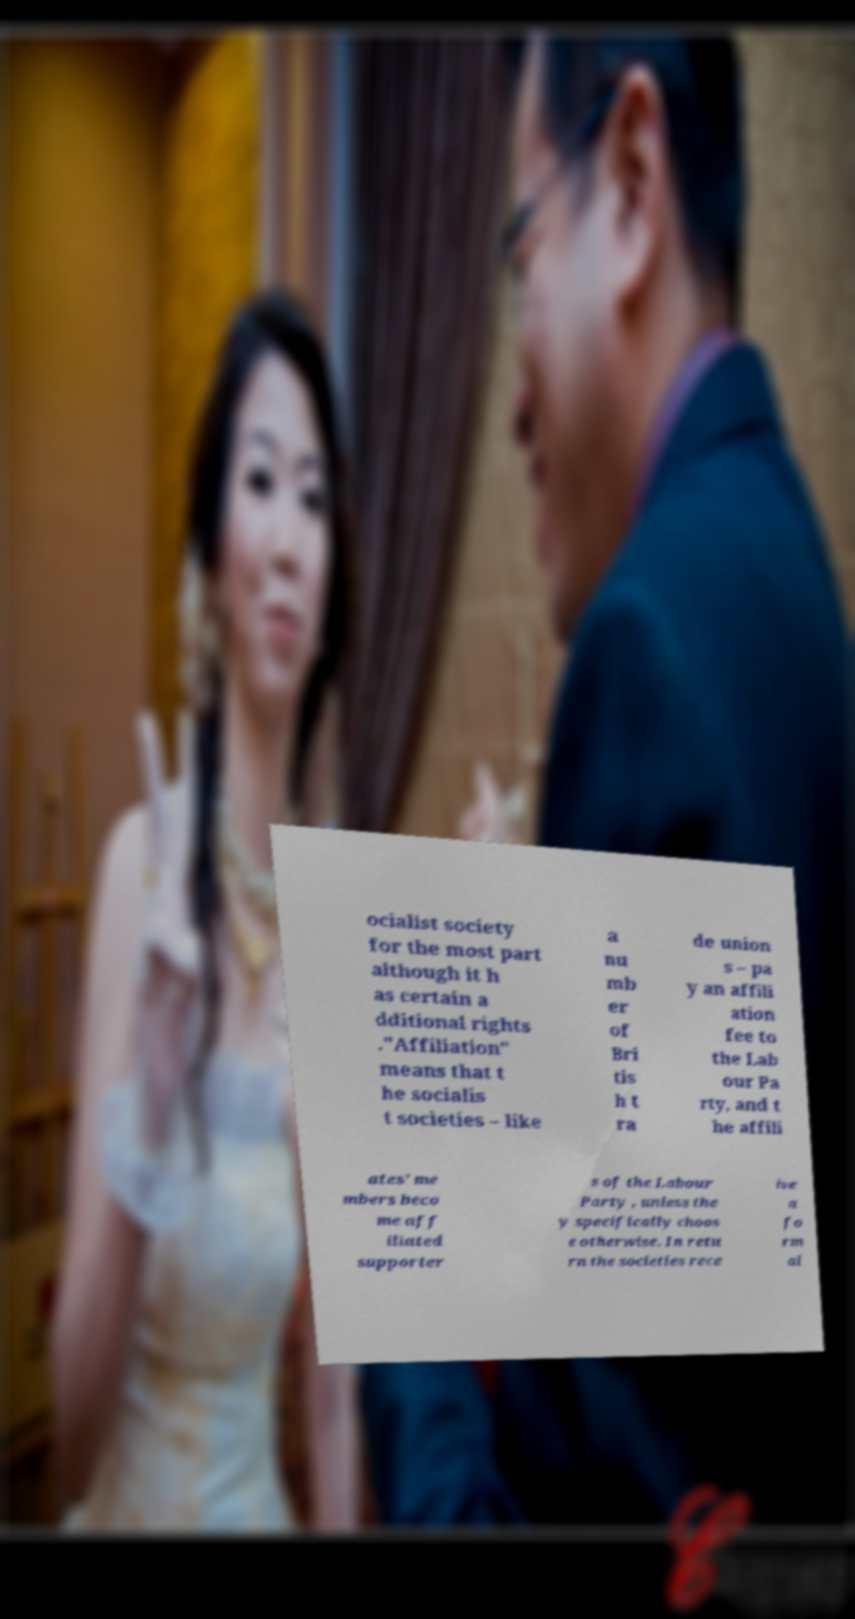For documentation purposes, I need the text within this image transcribed. Could you provide that? ocialist society for the most part although it h as certain a dditional rights ."Affiliation" means that t he socialis t societies – like a nu mb er of Bri tis h t ra de union s – pa y an affili ation fee to the Lab our Pa rty, and t he affili ates' me mbers beco me aff iliated supporter s of the Labour Party , unless the y specifically choos e otherwise. In retu rn the societies rece ive a fo rm al 